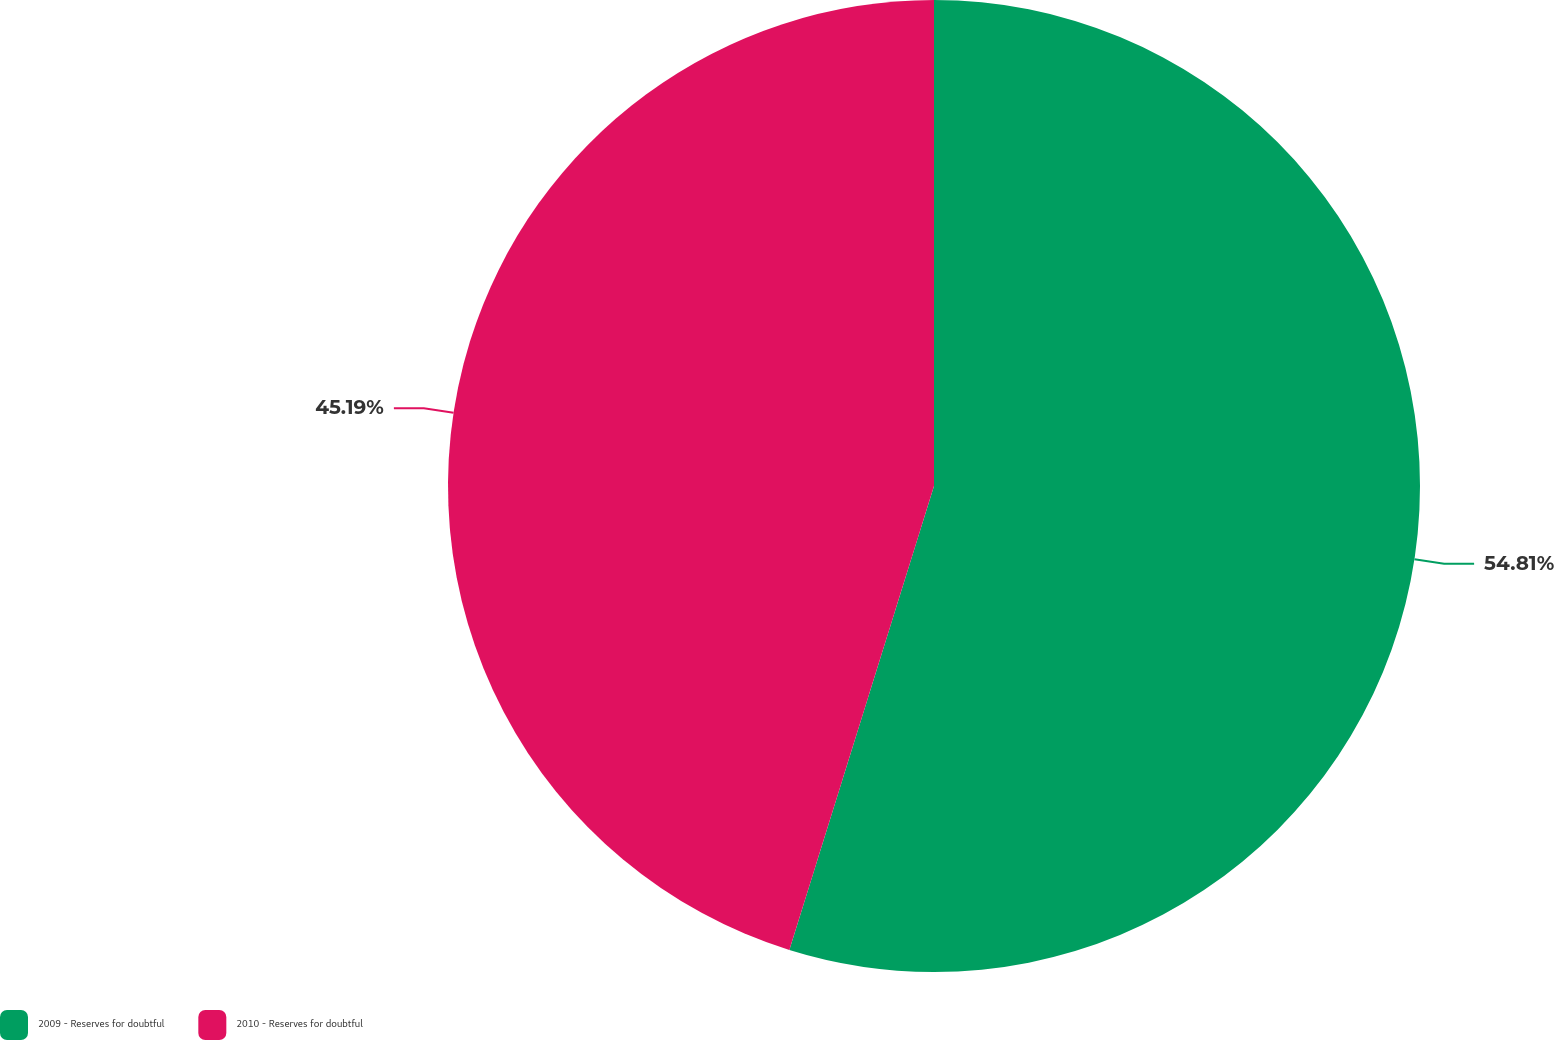<chart> <loc_0><loc_0><loc_500><loc_500><pie_chart><fcel>2009 - Reserves for doubtful<fcel>2010 - Reserves for doubtful<nl><fcel>54.81%<fcel>45.19%<nl></chart> 